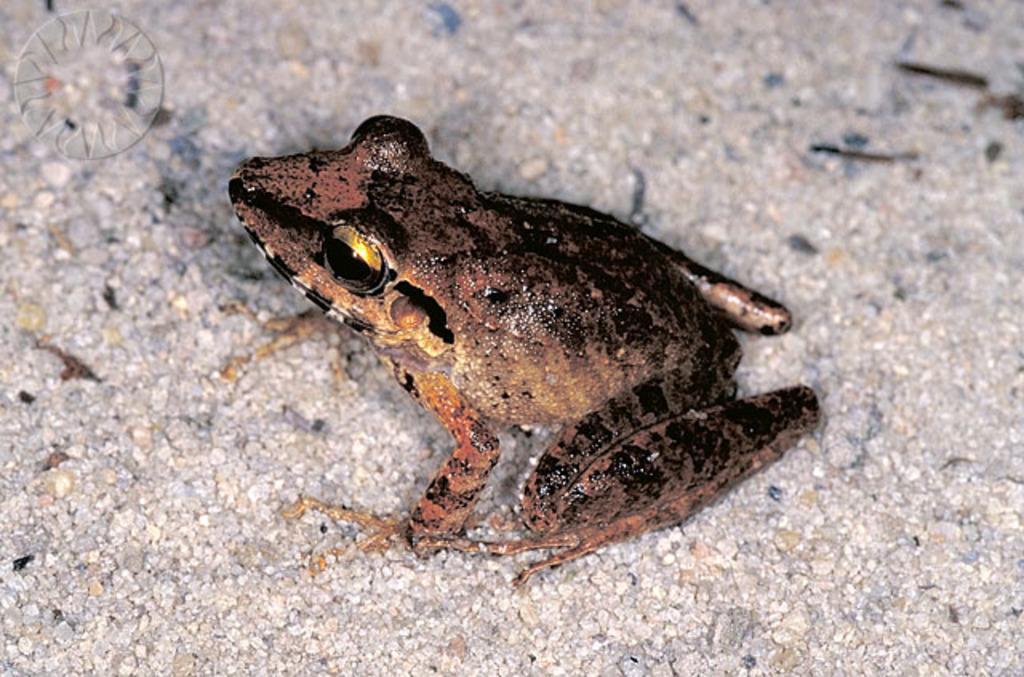In one or two sentences, can you explain what this image depicts? In this picture there is a frog in the center of the image. 